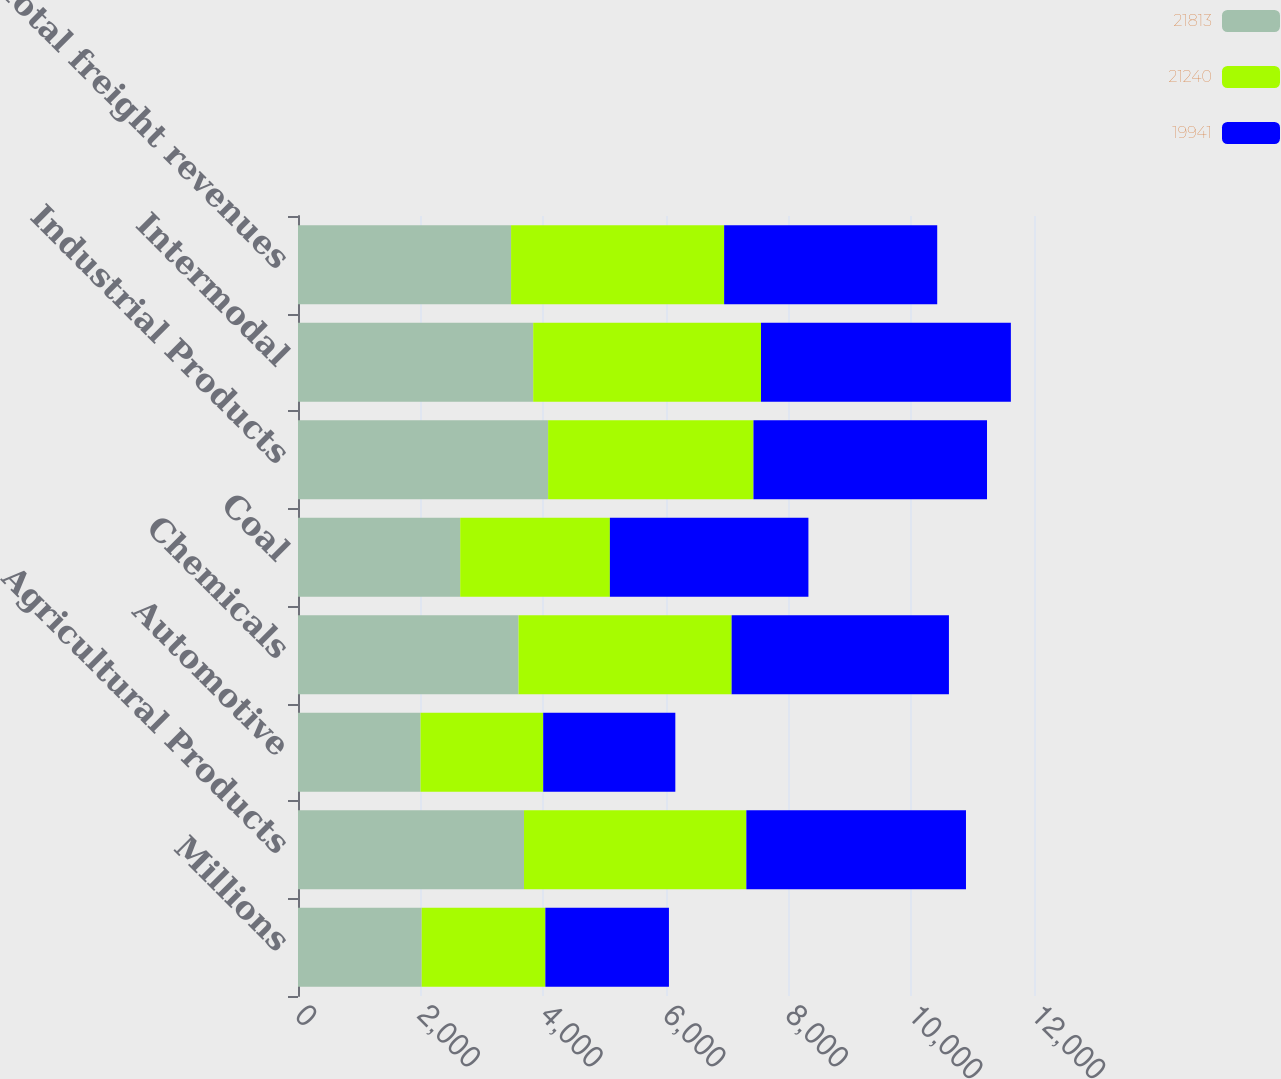Convert chart to OTSL. <chart><loc_0><loc_0><loc_500><loc_500><stacked_bar_chart><ecel><fcel>Millions<fcel>Agricultural Products<fcel>Automotive<fcel>Chemicals<fcel>Coal<fcel>Industrial Products<fcel>Intermodal<fcel>Total freight revenues<nl><fcel>21813<fcel>2017<fcel>3685<fcel>1998<fcel>3596<fcel>2645<fcel>4078<fcel>3835<fcel>3474<nl><fcel>21240<fcel>2016<fcel>3625<fcel>2000<fcel>3474<fcel>2440<fcel>3348<fcel>3714<fcel>3474<nl><fcel>19941<fcel>2015<fcel>3581<fcel>2154<fcel>3543<fcel>3237<fcel>3808<fcel>4074<fcel>3474<nl></chart> 